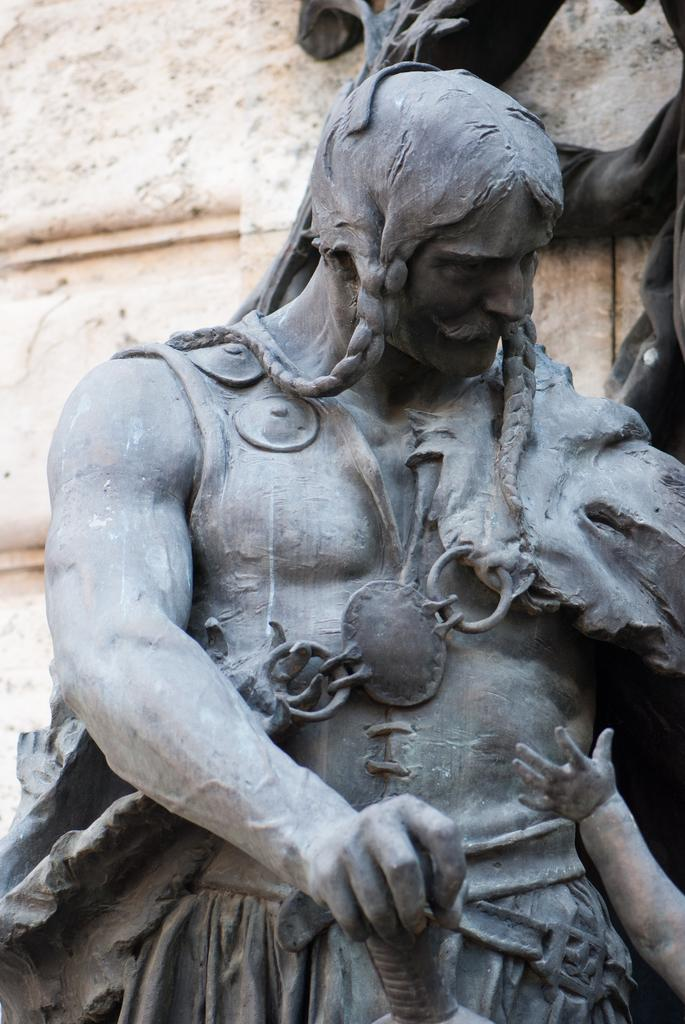What is the main subject in the image? There is a statue of a person in the image. What else can be seen in the image besides the statue? There is a wall visible in the image. What type of rake is being used by the person in the image? There is no rake present in the image; it features a statue of a person and a wall. What type of drum can be heard being played in the image? There is no drum present in the image, and therefore no sound of a drum can be heard. 